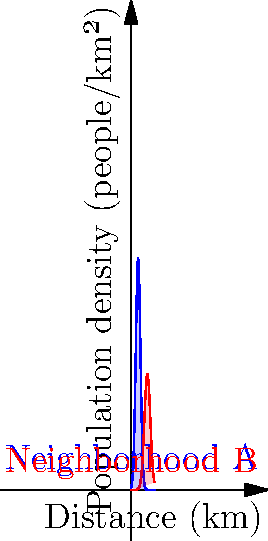As a local teacher, you're assisting in a community analysis project. The graph shows the population density of two neighborhoods (A and B) in your area. The x-axis represents the distance from the city center in kilometers, and the y-axis represents the population density in people per square kilometer. The blue curve represents Neighborhood A, and the red curve represents Neighborhood B.

Calculate the total population of Neighborhood A within 10 km of the city center, assuming the neighborhood extends radially around the center. Round your answer to the nearest thousand people. To solve this problem, we need to follow these steps:

1) The population density function for Neighborhood A is approximated by:
   $$f(x) = 100e^{-0.5(x-3)^2}$$
   where $x$ is the distance from the city center in kilometers.

2) To find the total population, we need to integrate this function over the given range (0 to 10 km) and multiply by $2\pi x$. This is because we're dealing with a circular area, and $2\pi x$ accounts for the increasing circumference as we move away from the center.

3) The integral we need to calculate is:
   $$P = \int_0^{10} 2\pi x \cdot 100e^{-0.5(x-3)^2} dx$$

4) This integral doesn't have a simple analytical solution, so we'll use numerical integration. We can use a numerical method like Simpson's rule or a computer algebra system.

5) Using a computer algebra system, we get:
   $$P \approx 5730.65$$

6) Rounding to the nearest thousand:
   $$P \approx 6000 \text{ people}$$

Therefore, the total population of Neighborhood A within 10 km of the city center is approximately 6,000 people.
Answer: 6,000 people 